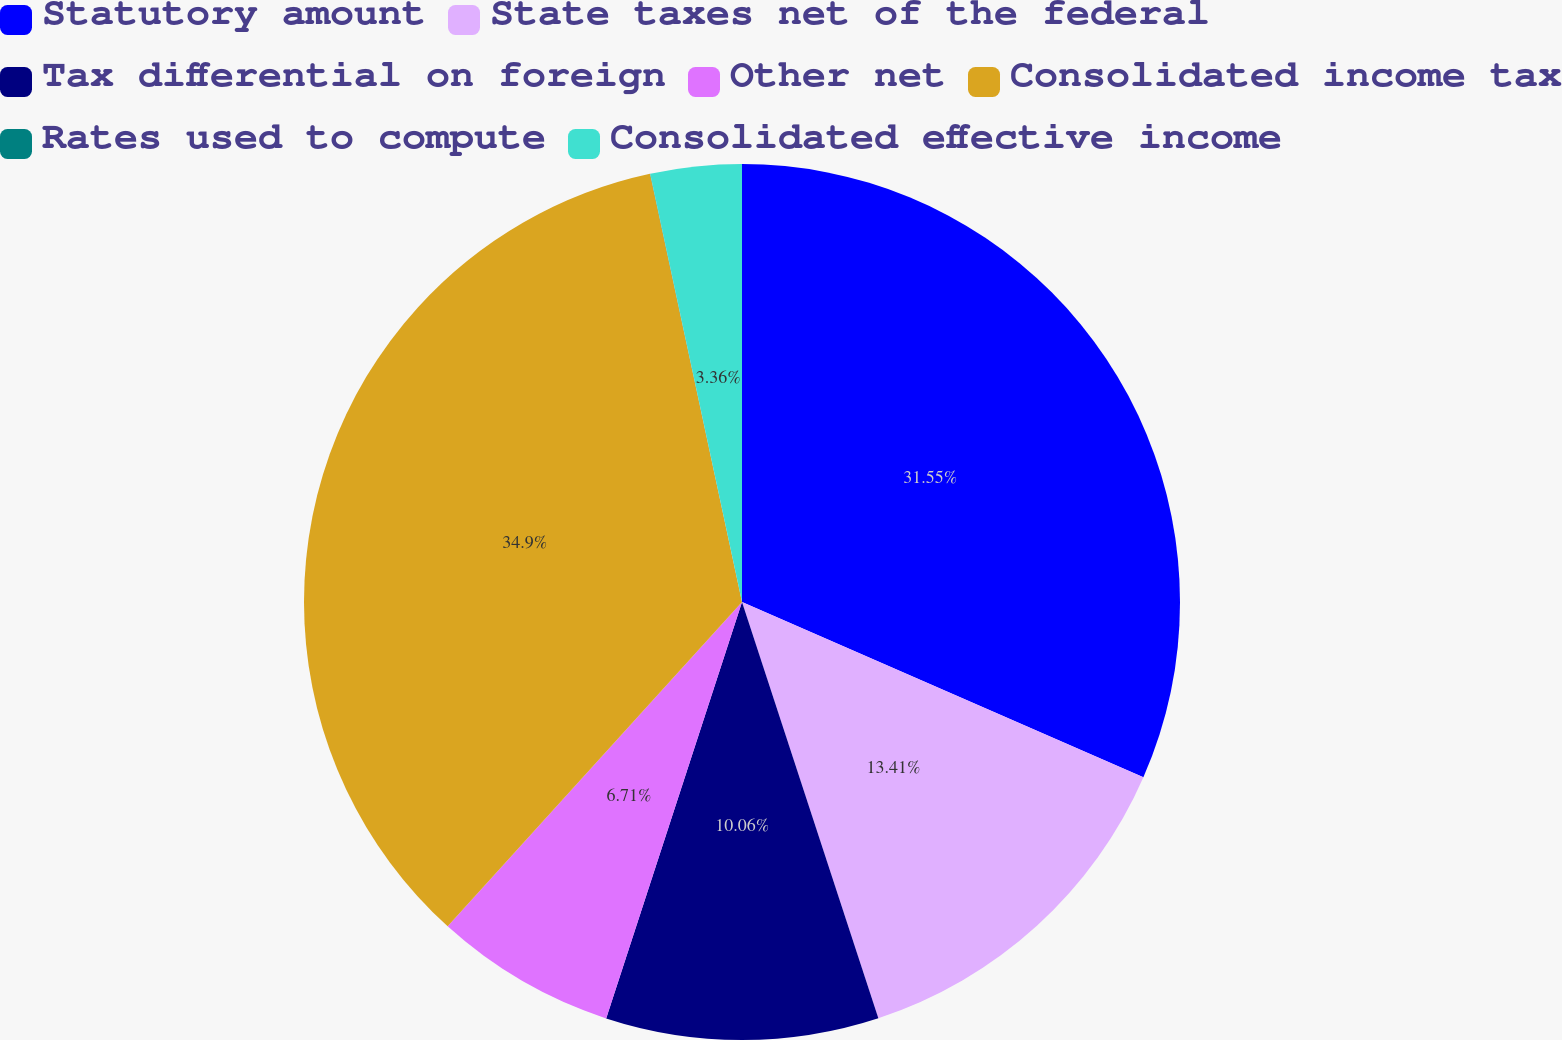Convert chart to OTSL. <chart><loc_0><loc_0><loc_500><loc_500><pie_chart><fcel>Statutory amount<fcel>State taxes net of the federal<fcel>Tax differential on foreign<fcel>Other net<fcel>Consolidated income tax<fcel>Rates used to compute<fcel>Consolidated effective income<nl><fcel>31.56%<fcel>13.41%<fcel>10.06%<fcel>6.71%<fcel>34.91%<fcel>0.01%<fcel>3.36%<nl></chart> 